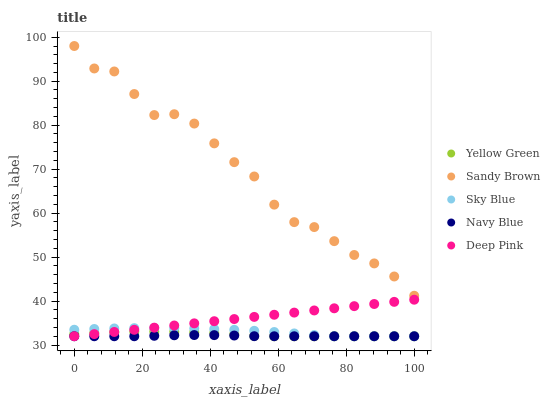Does Navy Blue have the minimum area under the curve?
Answer yes or no. Yes. Does Sandy Brown have the maximum area under the curve?
Answer yes or no. Yes. Does Deep Pink have the minimum area under the curve?
Answer yes or no. No. Does Deep Pink have the maximum area under the curve?
Answer yes or no. No. Is Deep Pink the smoothest?
Answer yes or no. Yes. Is Sandy Brown the roughest?
Answer yes or no. Yes. Is Sandy Brown the smoothest?
Answer yes or no. No. Is Deep Pink the roughest?
Answer yes or no. No. Does Sky Blue have the lowest value?
Answer yes or no. Yes. Does Sandy Brown have the lowest value?
Answer yes or no. No. Does Sandy Brown have the highest value?
Answer yes or no. Yes. Does Deep Pink have the highest value?
Answer yes or no. No. Is Deep Pink less than Sandy Brown?
Answer yes or no. Yes. Is Sandy Brown greater than Deep Pink?
Answer yes or no. Yes. Does Yellow Green intersect Sky Blue?
Answer yes or no. Yes. Is Yellow Green less than Sky Blue?
Answer yes or no. No. Is Yellow Green greater than Sky Blue?
Answer yes or no. No. Does Deep Pink intersect Sandy Brown?
Answer yes or no. No. 